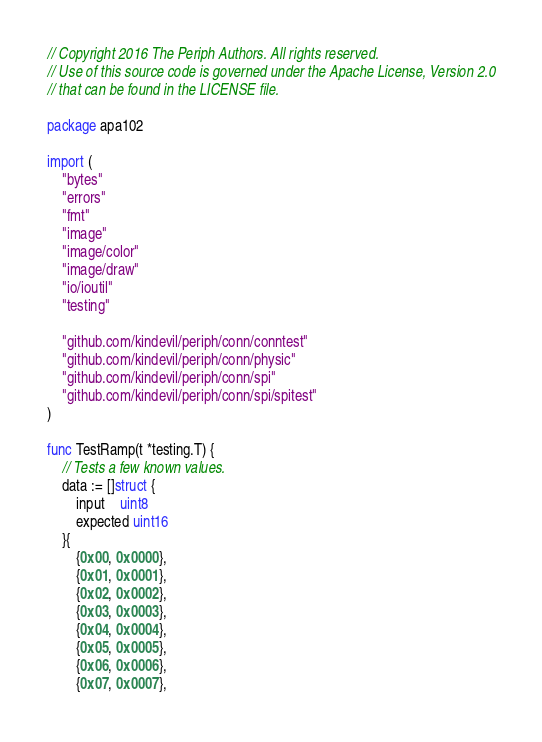<code> <loc_0><loc_0><loc_500><loc_500><_Go_>// Copyright 2016 The Periph Authors. All rights reserved.
// Use of this source code is governed under the Apache License, Version 2.0
// that can be found in the LICENSE file.

package apa102

import (
	"bytes"
	"errors"
	"fmt"
	"image"
	"image/color"
	"image/draw"
	"io/ioutil"
	"testing"

	"github.com/kindevil/periph/conn/conntest"
	"github.com/kindevil/periph/conn/physic"
	"github.com/kindevil/periph/conn/spi"
	"github.com/kindevil/periph/conn/spi/spitest"
)

func TestRamp(t *testing.T) {
	// Tests a few known values.
	data := []struct {
		input    uint8
		expected uint16
	}{
		{0x00, 0x0000},
		{0x01, 0x0001},
		{0x02, 0x0002},
		{0x03, 0x0003},
		{0x04, 0x0004},
		{0x05, 0x0005},
		{0x06, 0x0006},
		{0x07, 0x0007},</code> 